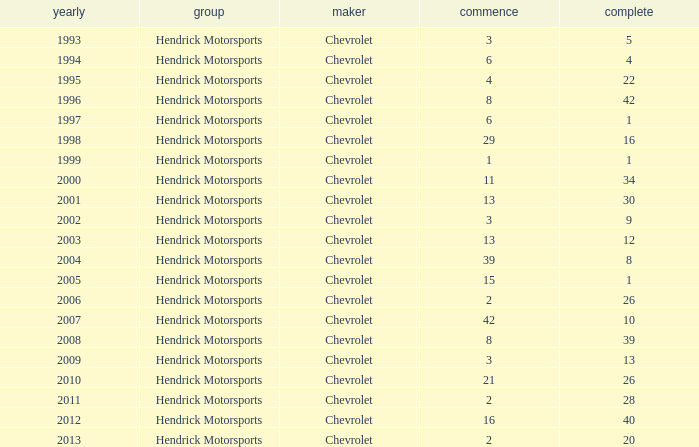What is the number of finishes having a start of 15? 1.0. 